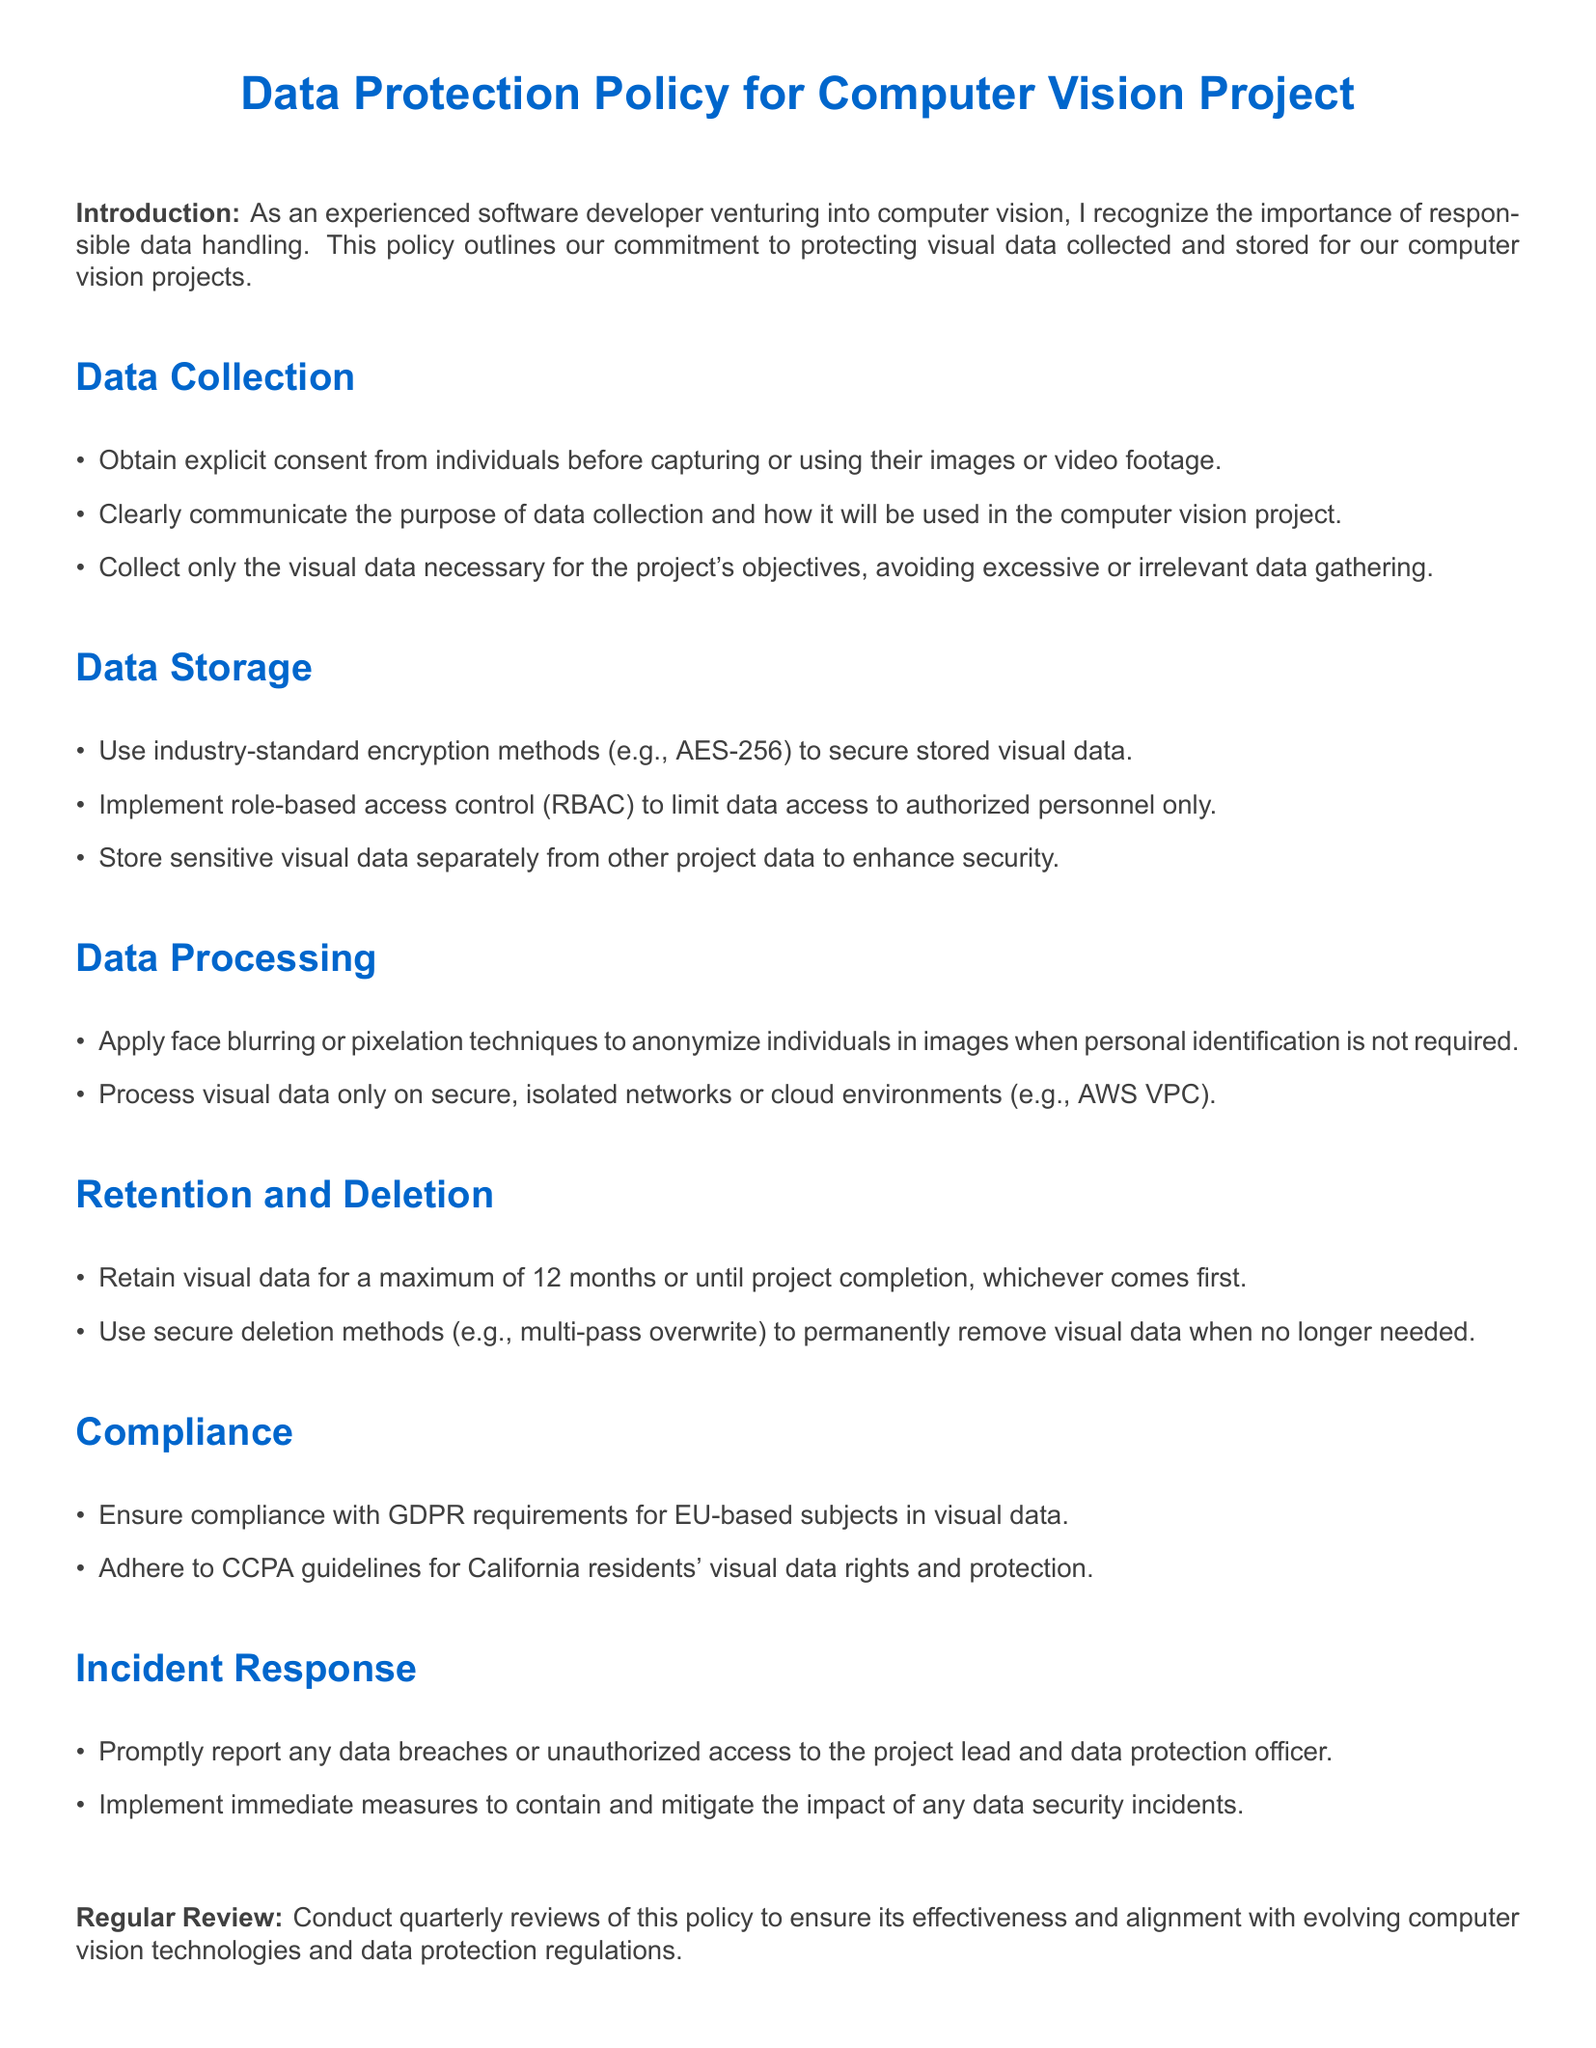what is the maximum data retention period? The document states that visual data should be retained for a maximum of 12 months or until project completion, whichever comes first.
Answer: 12 months what encryption method should be used for data storage? The policy specifies using industry-standard encryption methods for securing stored visual data, particularly mentioning AES-256.
Answer: AES-256 which regulation should be adhered to for California residents’ visual data rights? The document highlights the importance of compliance with data protection regulations, specifically mentioning CCPA for California residents.
Answer: CCPA what technique should be applied to anonymize individuals in images? The policy outlines that face blurring or pixelation techniques should be applied to anonymize individuals when personal identification is not required.
Answer: face blurring who should be promptly notified in case of a data breach? The document states that any data breaches or unauthorized access should be reported to the project lead and data protection officer.
Answer: project lead and data protection officer what is the purpose of the data collection section? The purpose of the data collection section is to outline guidelines to ensure responsible handling of visual data gathered for the computer vision project.
Answer: responsible handling how often should the data protection policy be reviewed? The document specifies that this policy should undergo quarterly reviews to ensure its effectiveness and alignment with evolving regulations.
Answer: quarterly what does RBAC stand for in the context of data access? In the document, RBAC refers to role-based access control, which is implemented to limit data access to authorized personnel only.
Answer: role-based access control what should be used to securely delete visual data? The policy emphasizes the use of secure deletion methods, specifically mentioning multi-pass overwrite for permanently removing visual data when no longer needed.
Answer: multi-pass overwrite 